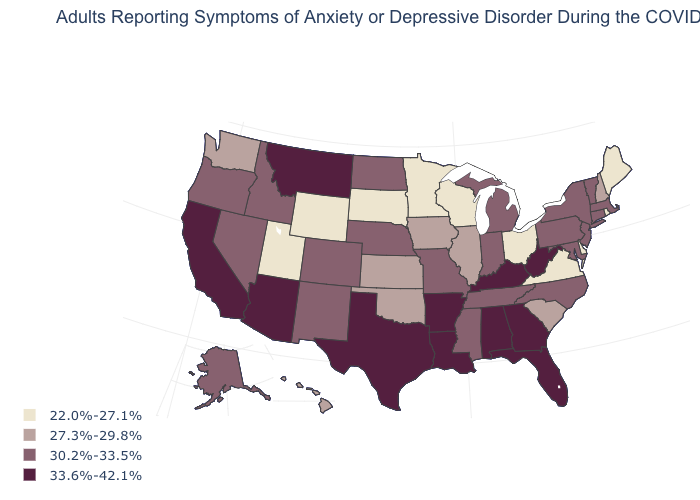What is the highest value in the MidWest ?
Short answer required. 30.2%-33.5%. Among the states that border Massachusetts , does Connecticut have the highest value?
Keep it brief. Yes. What is the value of Wisconsin?
Be succinct. 22.0%-27.1%. How many symbols are there in the legend?
Short answer required. 4. Name the states that have a value in the range 22.0%-27.1%?
Short answer required. Delaware, Maine, Minnesota, Ohio, Rhode Island, South Dakota, Utah, Virginia, Wisconsin, Wyoming. What is the lowest value in states that border Maryland?
Answer briefly. 22.0%-27.1%. Name the states that have a value in the range 30.2%-33.5%?
Give a very brief answer. Alaska, Colorado, Connecticut, Idaho, Indiana, Maryland, Massachusetts, Michigan, Mississippi, Missouri, Nebraska, Nevada, New Jersey, New Mexico, New York, North Carolina, North Dakota, Oregon, Pennsylvania, Tennessee, Vermont. Does Connecticut have the same value as Mississippi?
Give a very brief answer. Yes. What is the value of Iowa?
Give a very brief answer. 27.3%-29.8%. What is the value of Nevada?
Give a very brief answer. 30.2%-33.5%. Does New Jersey have a higher value than California?
Short answer required. No. Name the states that have a value in the range 30.2%-33.5%?
Concise answer only. Alaska, Colorado, Connecticut, Idaho, Indiana, Maryland, Massachusetts, Michigan, Mississippi, Missouri, Nebraska, Nevada, New Jersey, New Mexico, New York, North Carolina, North Dakota, Oregon, Pennsylvania, Tennessee, Vermont. What is the value of Massachusetts?
Quick response, please. 30.2%-33.5%. Name the states that have a value in the range 27.3%-29.8%?
Short answer required. Hawaii, Illinois, Iowa, Kansas, New Hampshire, Oklahoma, South Carolina, Washington. Among the states that border Mississippi , which have the highest value?
Answer briefly. Alabama, Arkansas, Louisiana. 